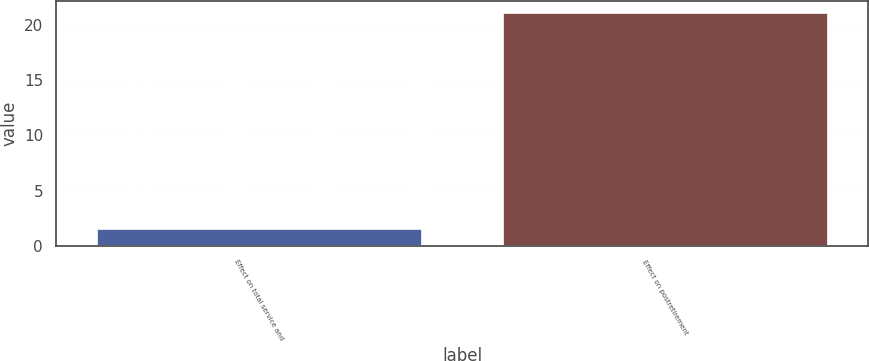Convert chart to OTSL. <chart><loc_0><loc_0><loc_500><loc_500><bar_chart><fcel>Effect on total service and<fcel>Effect on postretirement<nl><fcel>1.5<fcel>21.1<nl></chart> 